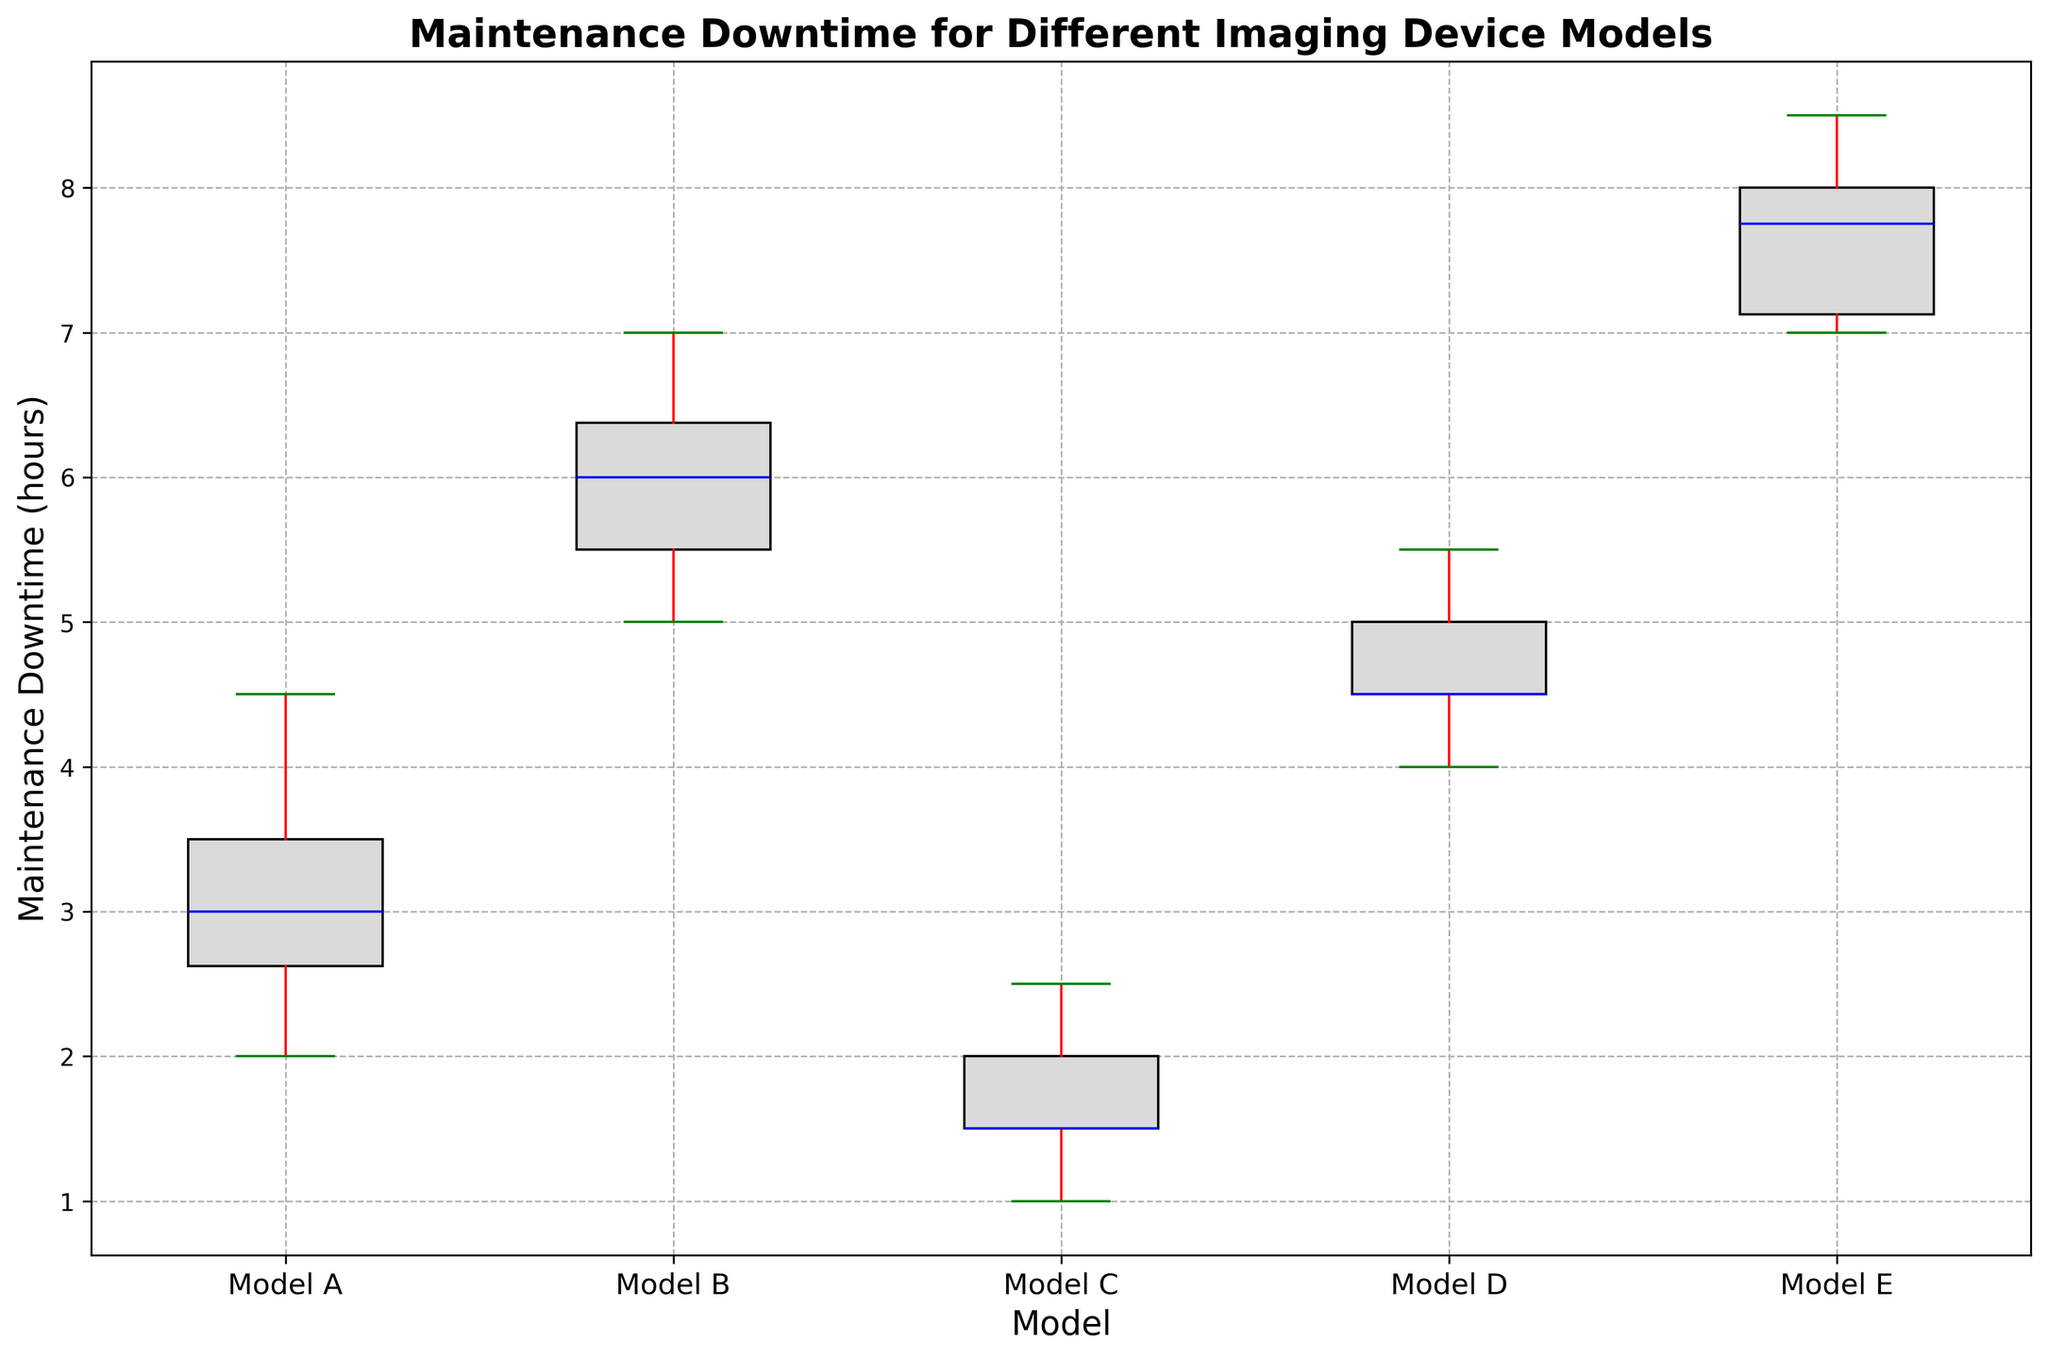What is the range of maintenance downtime for Model C? The range is calculated by subtracting the minimum value from the maximum value. From the box plot, Model C has a minimum downtime of 1 hour and a maximum of 2.5 hours. Therefore, the range is 2.5 - 1 = 1.5 hours.
Answer: 1.5 hours Which model has the highest median maintenance downtime? The median is represented by the horizontal line inside each box. From the box plot, Model E has the highest median maintenance downtime, which appears to be around 7.5 hours.
Answer: Model E How does the variability in maintenance downtime for Model A compare to Model B? Variability can be assessed by the length of the box (interquartile range - IQR) and the length of the whiskers. Model B has a larger IQR and whiskers than Model A, indicating higher variability in maintenance downtime.
Answer: Model B has higher variability What is the interquartile range of maintenance downtime for Model D? The interquartile range (IQR) is the difference between the third quartile (Q3) and the first quartile (Q1). From the box plot, Q3 for Model D appears to be 5 hours and Q1 is about 4.5 hours. Therefore, the IQR is 5 - 4.5 = 0.5 hours.
Answer: 0.5 hours Which model has the smallest spread in its maintenance downtime, and how did you determine that? The spread can be gauged by the length of the whiskers and the IQR. Model C shows the smallest spread, with very short whiskers and a small IQR, indicating low variability in maintenance downtime.
Answer: Model C What is the median maintenance downtime for Model A? The median is the central value represented by the horizontal line within the box. For Model A, the median appears to be around 3 hours, based on the box plot.
Answer: 3 hours How many models have an upper whisker that extends beyond 7 hours? The upper whisker extends beyond 7 hours for Model B and Model E, making a total of 2 models.
Answer: 2 models Between Model A and Model D, which one has a higher upper quartile (Q3) value? The upper quartile (Q3) is the top edge of the box. Comparing the boxes for Model A and Model D, Model D has a higher Q3 value than Model A.
Answer: Model D Which model has the most outliers, and how can you tell? Outliers are shown as individual points outside the whiskers. From the box plot, Model E has several outliers, identified as points beyond the maximum and minimum whiskers.
Answer: Model E What is the median maintenance downtime for Model B? The median is shown by the horizontal line within the box. For Model B, the median downtime appears to be around 6 hours.
Answer: 6 hours 